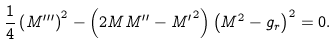<formula> <loc_0><loc_0><loc_500><loc_500>\frac { 1 } { 4 } \left ( { M ^ { \prime \prime \prime } } \right ) ^ { 2 } - \left ( 2 M M ^ { \prime \prime } - { M ^ { \prime } } ^ { 2 } \right ) \left ( M ^ { 2 } - g _ { r } \right ) ^ { 2 } = 0 .</formula> 